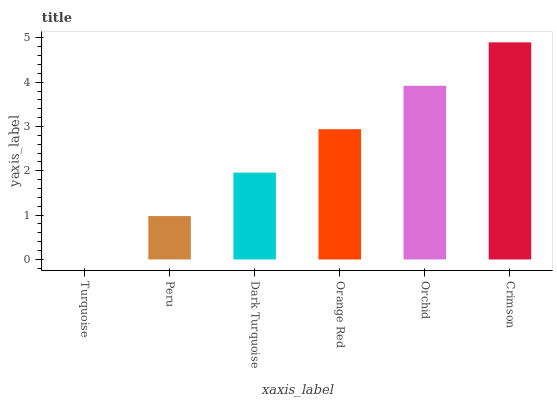Is Turquoise the minimum?
Answer yes or no. Yes. Is Crimson the maximum?
Answer yes or no. Yes. Is Peru the minimum?
Answer yes or no. No. Is Peru the maximum?
Answer yes or no. No. Is Peru greater than Turquoise?
Answer yes or no. Yes. Is Turquoise less than Peru?
Answer yes or no. Yes. Is Turquoise greater than Peru?
Answer yes or no. No. Is Peru less than Turquoise?
Answer yes or no. No. Is Orange Red the high median?
Answer yes or no. Yes. Is Dark Turquoise the low median?
Answer yes or no. Yes. Is Orchid the high median?
Answer yes or no. No. Is Orange Red the low median?
Answer yes or no. No. 